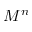<formula> <loc_0><loc_0><loc_500><loc_500>M ^ { n }</formula> 